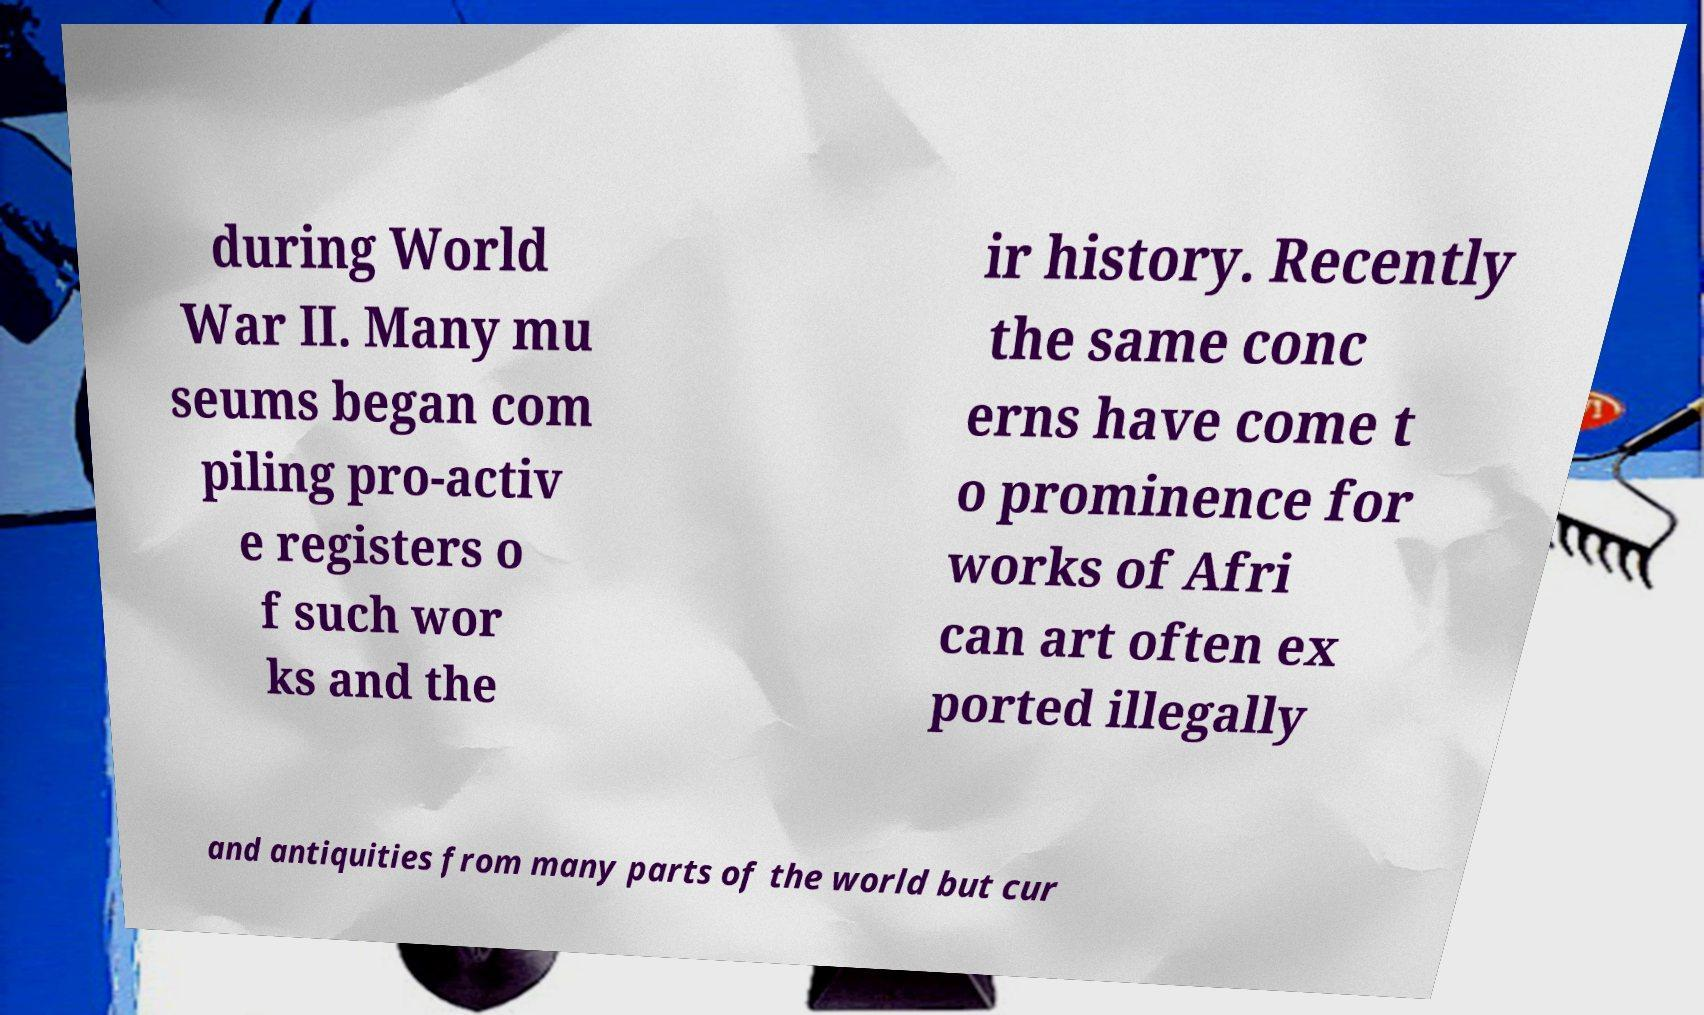For documentation purposes, I need the text within this image transcribed. Could you provide that? during World War II. Many mu seums began com piling pro-activ e registers o f such wor ks and the ir history. Recently the same conc erns have come t o prominence for works of Afri can art often ex ported illegally and antiquities from many parts of the world but cur 